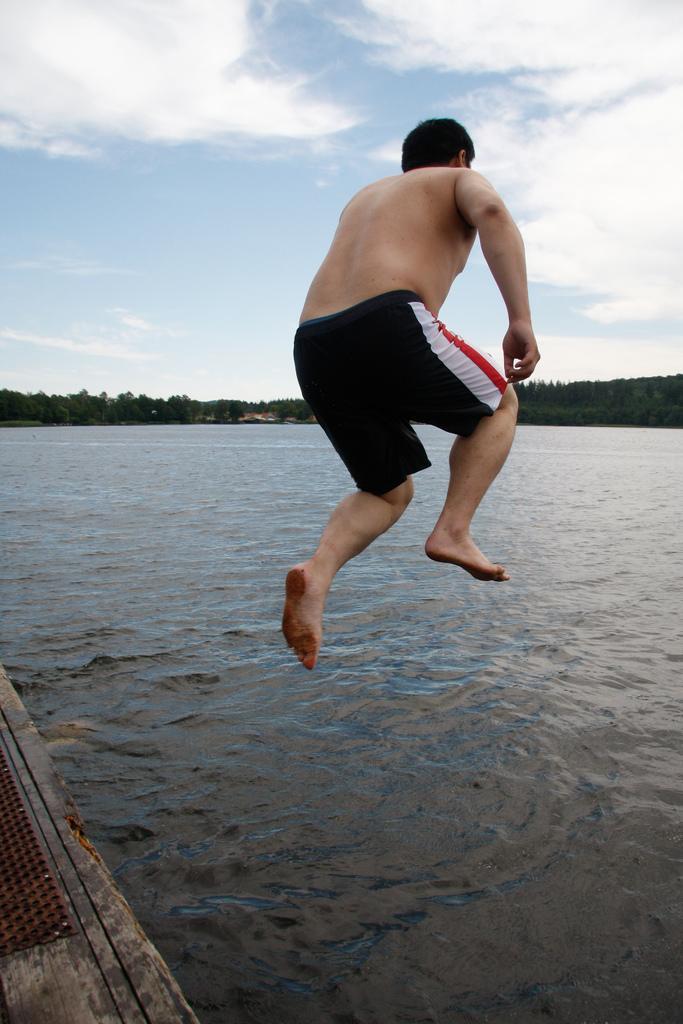Could you give a brief overview of what you see in this image? In this image there is a man jumping. There is the water in the image. In the bottom left there is a wooden surface. In the background there are trees. At the top there is the sky. 